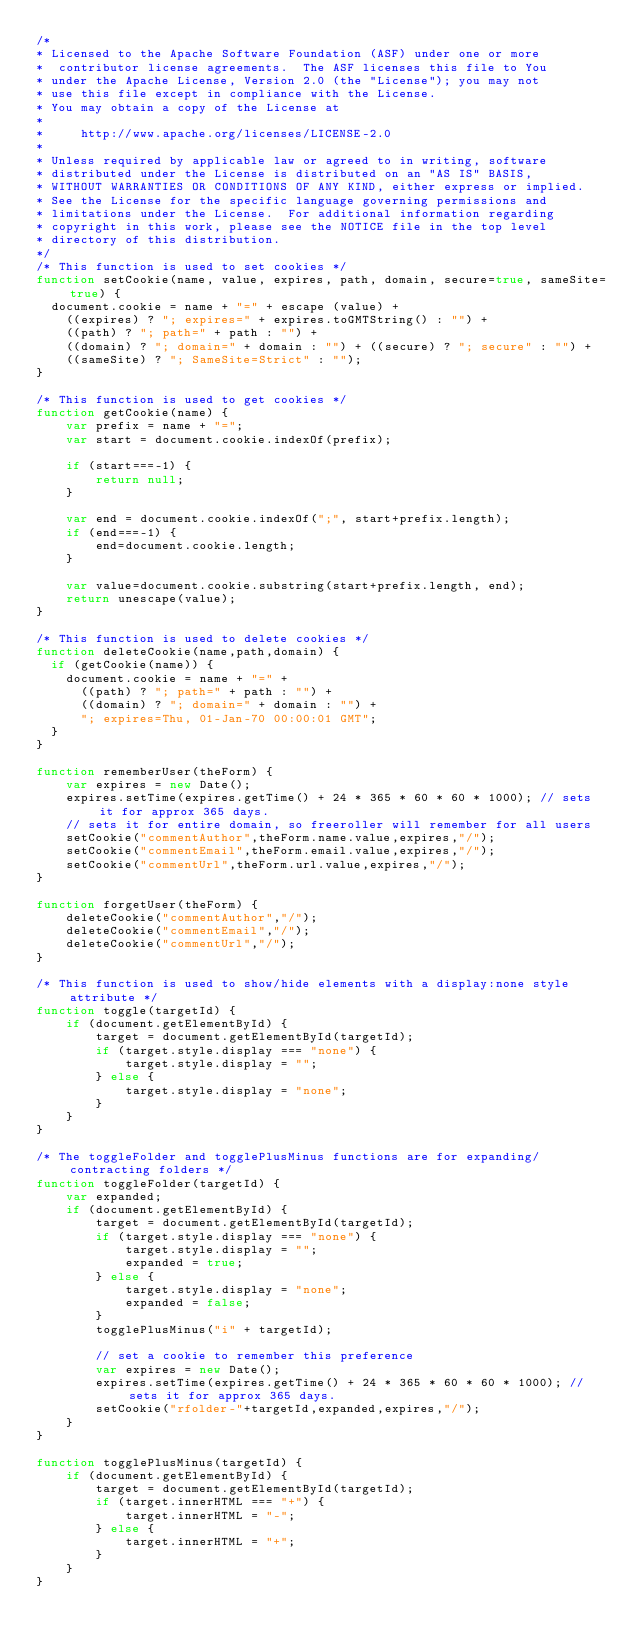<code> <loc_0><loc_0><loc_500><loc_500><_JavaScript_>/*
* Licensed to the Apache Software Foundation (ASF) under one or more
*  contributor license agreements.  The ASF licenses this file to You
* under the Apache License, Version 2.0 (the "License"); you may not
* use this file except in compliance with the License.
* You may obtain a copy of the License at
*
*     http://www.apache.org/licenses/LICENSE-2.0
*
* Unless required by applicable law or agreed to in writing, software
* distributed under the License is distributed on an "AS IS" BASIS,
* WITHOUT WARRANTIES OR CONDITIONS OF ANY KIND, either express or implied.
* See the License for the specific language governing permissions and
* limitations under the License.  For additional information regarding
* copyright in this work, please see the NOTICE file in the top level
* directory of this distribution.
*/
/* This function is used to set cookies */
function setCookie(name, value, expires, path, domain, secure=true, sameSite=true) {
  document.cookie = name + "=" + escape (value) +
    ((expires) ? "; expires=" + expires.toGMTString() : "") +
    ((path) ? "; path=" + path : "") +
    ((domain) ? "; domain=" + domain : "") + ((secure) ? "; secure" : "") +
    ((sameSite) ? "; SameSite=Strict" : "");
}

/* This function is used to get cookies */
function getCookie(name) {
	var prefix = name + "=";
	var start = document.cookie.indexOf(prefix);

	if (start===-1) {
		return null;
	}

	var end = document.cookie.indexOf(";", start+prefix.length);
	if (end===-1) {
		end=document.cookie.length;
	}

	var value=document.cookie.substring(start+prefix.length, end);
	return unescape(value);
}

/* This function is used to delete cookies */
function deleteCookie(name,path,domain) {
  if (getCookie(name)) {
    document.cookie = name + "=" +
      ((path) ? "; path=" + path : "") +
      ((domain) ? "; domain=" + domain : "") +
      "; expires=Thu, 01-Jan-70 00:00:01 GMT";
  }
}

function rememberUser(theForm) {
    var expires = new Date();
    expires.setTime(expires.getTime() + 24 * 365 * 60 * 60 * 1000); // sets it for approx 365 days.
    // sets it for entire domain, so freeroller will remember for all users
    setCookie("commentAuthor",theForm.name.value,expires,"/");
    setCookie("commentEmail",theForm.email.value,expires,"/");
    setCookie("commentUrl",theForm.url.value,expires,"/");
}

function forgetUser(theForm) {
    deleteCookie("commentAuthor","/");
    deleteCookie("commentEmail","/");
    deleteCookie("commentUrl","/");
}

/* This function is used to show/hide elements with a display:none style attribute */
function toggle(targetId) {
    if (document.getElementById) {
        target = document.getElementById(targetId);
    	if (target.style.display === "none") {
    		target.style.display = "";
    	} else {
    		target.style.display = "none";
    	}
    }
}

/* The toggleFolder and togglePlusMinus functions are for expanding/contracting folders */
function toggleFolder(targetId) {
    var expanded;
    if (document.getElementById) {
        target = document.getElementById(targetId);
    	if (target.style.display === "none") {
    		target.style.display = "";
            expanded = true;
    	} else {
    		target.style.display = "none";
            expanded = false;
    	}
        togglePlusMinus("i" + targetId);

        // set a cookie to remember this preference
        var expires = new Date();
        expires.setTime(expires.getTime() + 24 * 365 * 60 * 60 * 1000); // sets it for approx 365 days.
        setCookie("rfolder-"+targetId,expanded,expires,"/");
    }
}

function togglePlusMinus(targetId) {
    if (document.getElementById) {
        target = document.getElementById(targetId);
    	if (target.innerHTML === "+") {
    		target.innerHTML = "-";
    	} else {
    		target.innerHTML = "+";
    	}
    }
}
</code> 